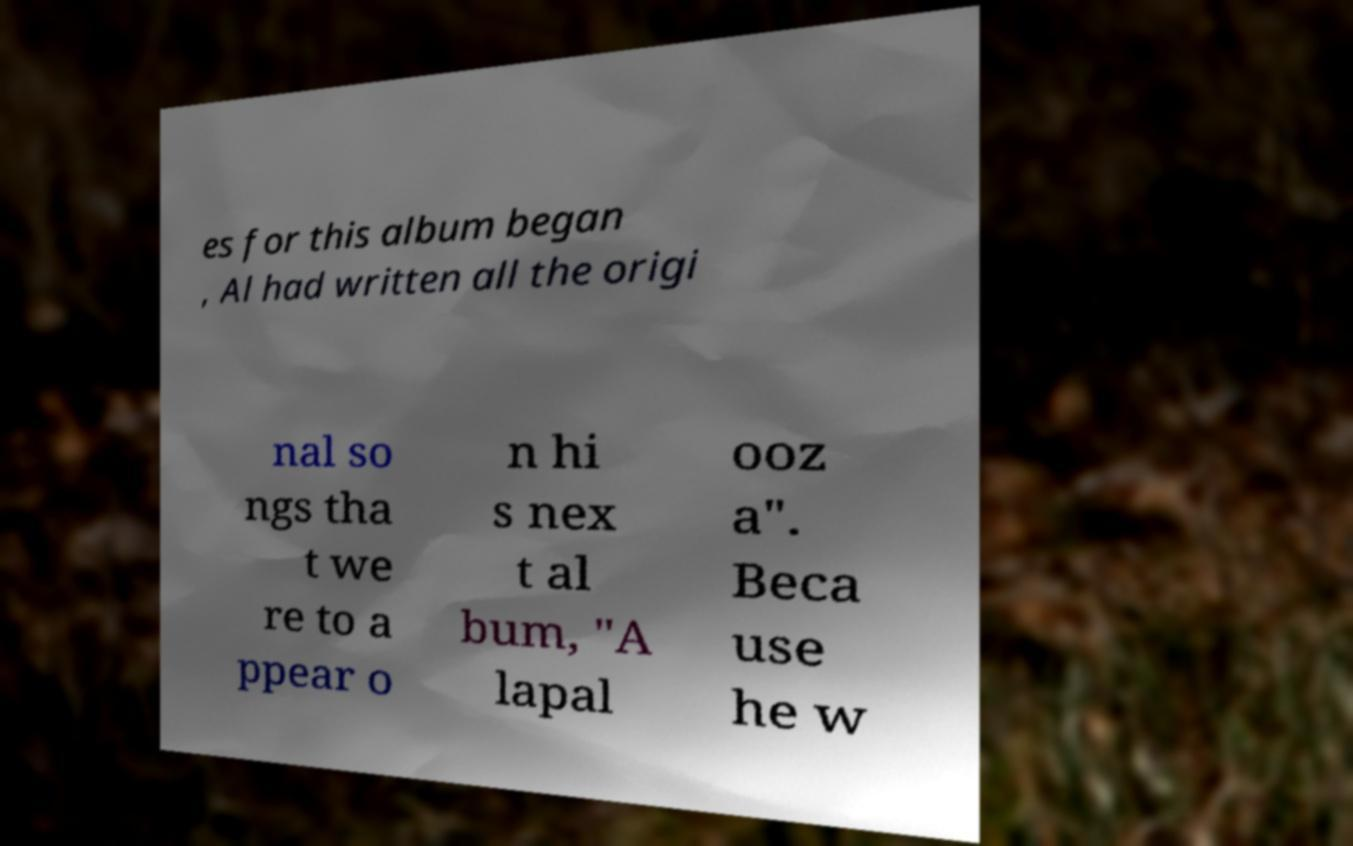Can you accurately transcribe the text from the provided image for me? es for this album began , Al had written all the origi nal so ngs tha t we re to a ppear o n hi s nex t al bum, "A lapal ooz a". Beca use he w 